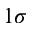Convert formula to latex. <formula><loc_0><loc_0><loc_500><loc_500>1 \sigma</formula> 